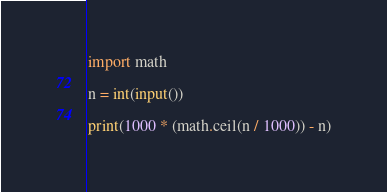Convert code to text. <code><loc_0><loc_0><loc_500><loc_500><_Python_>import math

n = int(input())

print(1000 * (math.ceil(n / 1000)) - n)</code> 